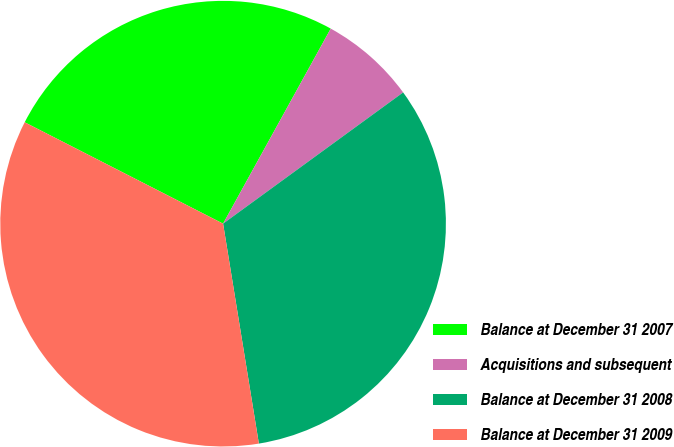Convert chart. <chart><loc_0><loc_0><loc_500><loc_500><pie_chart><fcel>Balance at December 31 2007<fcel>Acquisitions and subsequent<fcel>Balance at December 31 2008<fcel>Balance at December 31 2009<nl><fcel>25.51%<fcel>6.95%<fcel>32.46%<fcel>35.09%<nl></chart> 